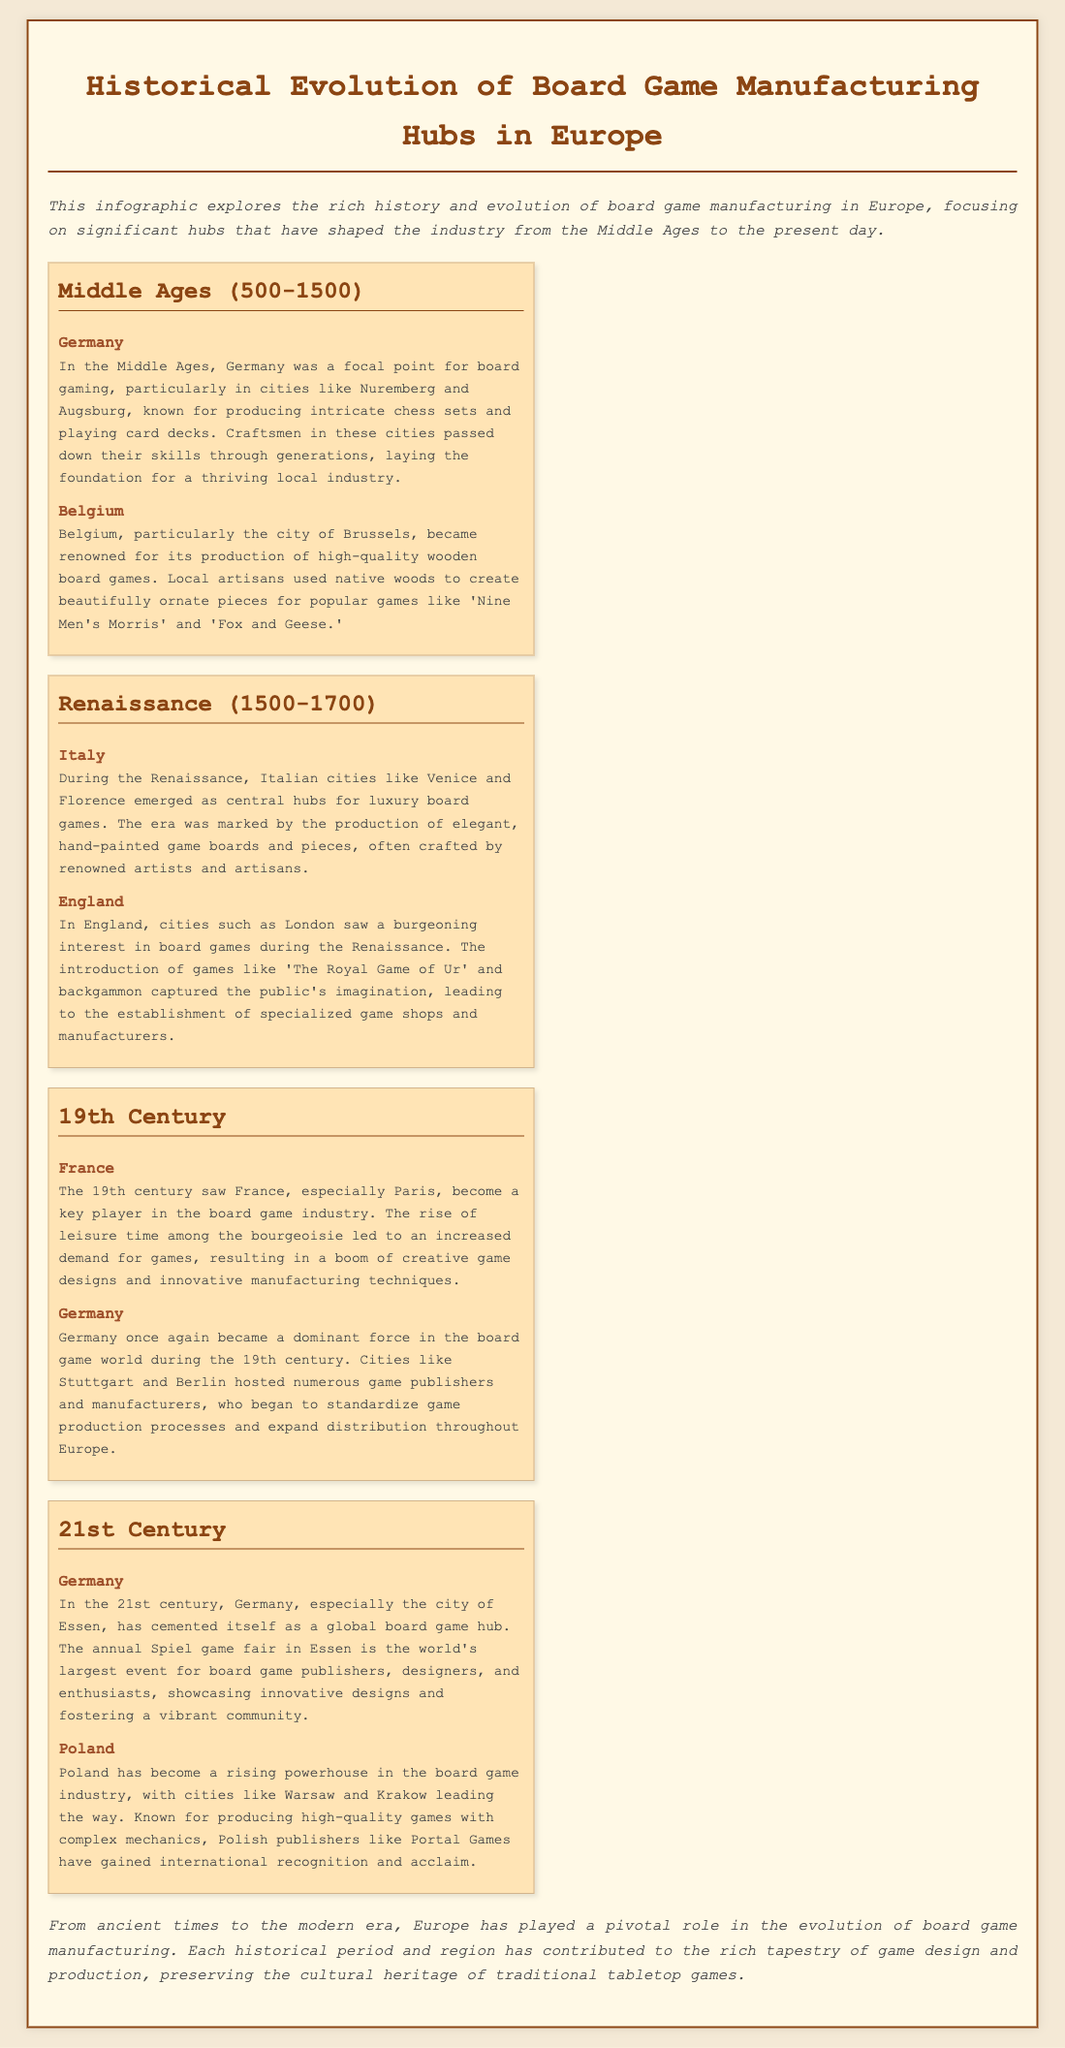What was a significant city in Germany during the Middle Ages for board game manufacturing? The document states that cities like Nuremberg and Augsburg were known for their board game production in Germany during the Middle Ages.
Answer: Nuremberg Which country produced high-quality wooden board games in the Middle Ages? The document mentions that Belgium, particularly Brussels, was renowned for its wooden board games during the Middle Ages.
Answer: Belgium What unique products were created in Italy during the Renaissance? It explains that Italian cities like Venice and Florence produced luxury board games, particularly hand-painted boards and pieces.
Answer: Luxury board games What city in France became key in the 19th century board game industry? The document highlights Paris as a key player in the board game industry during the 19th century.
Answer: Paris In which century did Germany regain dominance in the board game world? The document indicates that Germany became dominant again in the 19th century.
Answer: 19th Century What is the world's largest event for board game publishers? The document describes the annual Spiel game fair in Essen as the largest event for board game publishers, designers, and enthusiasts.
Answer: Spiel game fair What rising powerhouse in the board game industry is mentioned in the 21st century? The document notes that Poland has become a rising powerhouse in the board game industry.
Answer: Poland Which city is specifically noted for hosting the Spiel game fair? According to the document, the city of Essen is highlighted for hosting the Spiel game fair.
Answer: Essen Why did demand for games increase in 19th century France? The document states that the rise of leisure time among the bourgeoisie led to an increased demand for games in France.
Answer: Leisure time among the bourgeoisie 